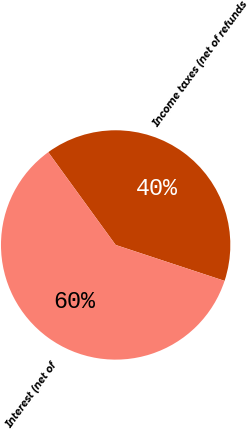Convert chart. <chart><loc_0><loc_0><loc_500><loc_500><pie_chart><fcel>Income taxes (net of refunds<fcel>Interest (net of<nl><fcel>40.07%<fcel>59.93%<nl></chart> 